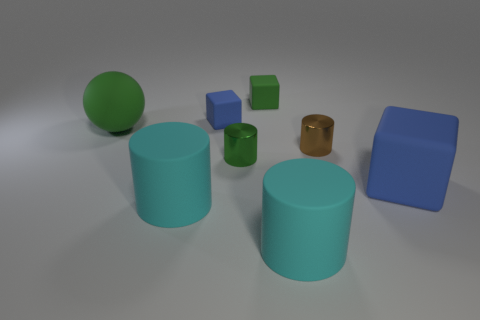How many other objects are there of the same color as the ball?
Your answer should be compact. 2. Is the number of big green matte balls less than the number of tiny metallic cylinders?
Your answer should be very brief. Yes. There is a blue thing to the right of the blue matte cube behind the matte ball; what is its shape?
Offer a terse response. Cube. Are there any small blocks to the left of the green metallic object?
Provide a succinct answer. Yes. What is the color of the metallic cylinder that is the same size as the brown object?
Keep it short and to the point. Green. What number of large green things are made of the same material as the brown cylinder?
Give a very brief answer. 0. What number of other objects are the same size as the ball?
Offer a terse response. 3. Are there any gray matte objects that have the same size as the green cube?
Offer a very short reply. No. There is a metal cylinder that is in front of the brown metallic object; is its color the same as the big block?
Your answer should be very brief. No. How many objects are either large cylinders or tiny brown metal things?
Your answer should be compact. 3. 